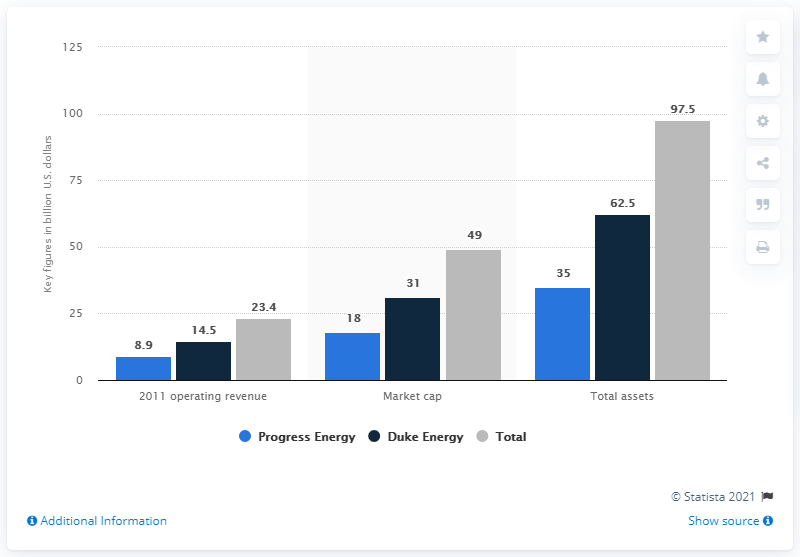List a handful of essential elements in this visual. As of June 2012, the assets of Progress Energy were approximately $35 million. 